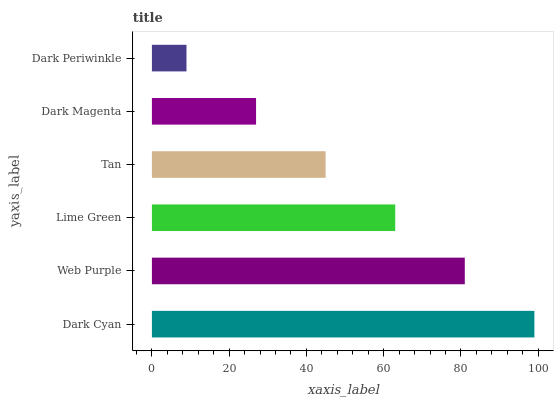Is Dark Periwinkle the minimum?
Answer yes or no. Yes. Is Dark Cyan the maximum?
Answer yes or no. Yes. Is Web Purple the minimum?
Answer yes or no. No. Is Web Purple the maximum?
Answer yes or no. No. Is Dark Cyan greater than Web Purple?
Answer yes or no. Yes. Is Web Purple less than Dark Cyan?
Answer yes or no. Yes. Is Web Purple greater than Dark Cyan?
Answer yes or no. No. Is Dark Cyan less than Web Purple?
Answer yes or no. No. Is Lime Green the high median?
Answer yes or no. Yes. Is Tan the low median?
Answer yes or no. Yes. Is Tan the high median?
Answer yes or no. No. Is Dark Cyan the low median?
Answer yes or no. No. 